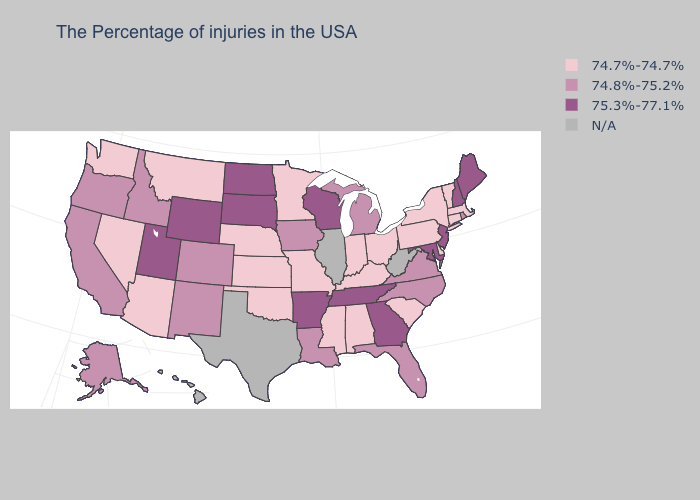What is the highest value in the MidWest ?
Short answer required. 75.3%-77.1%. Which states have the highest value in the USA?
Quick response, please. Maine, New Hampshire, New Jersey, Maryland, Georgia, Tennessee, Wisconsin, Arkansas, South Dakota, North Dakota, Wyoming, Utah. Which states have the highest value in the USA?
Keep it brief. Maine, New Hampshire, New Jersey, Maryland, Georgia, Tennessee, Wisconsin, Arkansas, South Dakota, North Dakota, Wyoming, Utah. What is the lowest value in states that border Oklahoma?
Answer briefly. 74.7%-74.7%. What is the value of West Virginia?
Quick response, please. N/A. Does Georgia have the lowest value in the South?
Be succinct. No. Name the states that have a value in the range 74.7%-74.7%?
Give a very brief answer. Massachusetts, Vermont, Connecticut, New York, Delaware, Pennsylvania, South Carolina, Ohio, Kentucky, Indiana, Alabama, Mississippi, Missouri, Minnesota, Kansas, Nebraska, Oklahoma, Montana, Arizona, Nevada, Washington. How many symbols are there in the legend?
Give a very brief answer. 4. Among the states that border West Virginia , does Maryland have the highest value?
Write a very short answer. Yes. Name the states that have a value in the range N/A?
Write a very short answer. West Virginia, Illinois, Texas, Hawaii. Name the states that have a value in the range 74.7%-74.7%?
Answer briefly. Massachusetts, Vermont, Connecticut, New York, Delaware, Pennsylvania, South Carolina, Ohio, Kentucky, Indiana, Alabama, Mississippi, Missouri, Minnesota, Kansas, Nebraska, Oklahoma, Montana, Arizona, Nevada, Washington. Name the states that have a value in the range 74.7%-74.7%?
Concise answer only. Massachusetts, Vermont, Connecticut, New York, Delaware, Pennsylvania, South Carolina, Ohio, Kentucky, Indiana, Alabama, Mississippi, Missouri, Minnesota, Kansas, Nebraska, Oklahoma, Montana, Arizona, Nevada, Washington. Does the first symbol in the legend represent the smallest category?
Concise answer only. Yes. Name the states that have a value in the range 75.3%-77.1%?
Write a very short answer. Maine, New Hampshire, New Jersey, Maryland, Georgia, Tennessee, Wisconsin, Arkansas, South Dakota, North Dakota, Wyoming, Utah. 